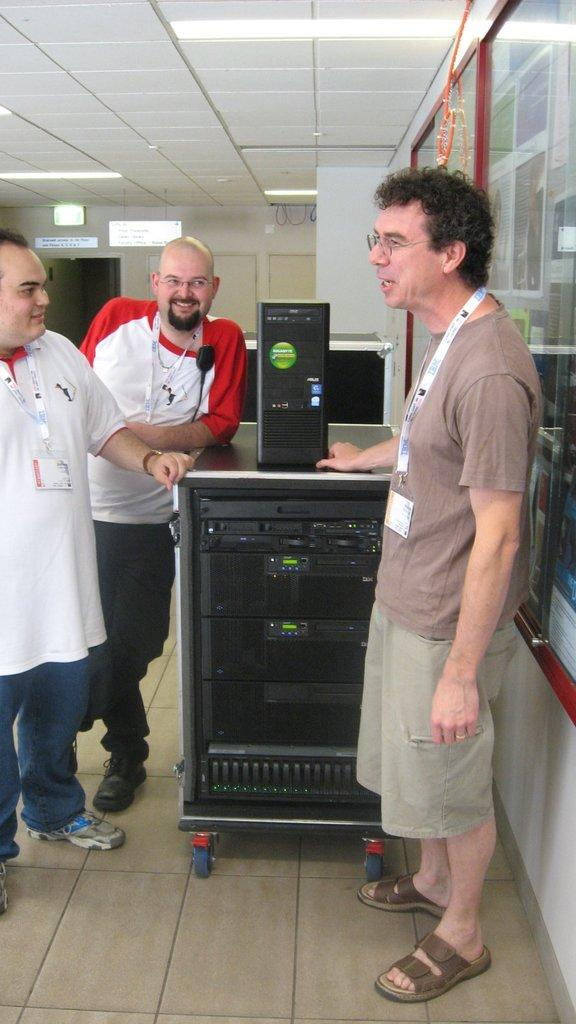How many people are in the image? There are three people in the image. What are the people doing in the image? The people are smiling in the image. Where are the people standing in the image? The people are standing on the floor in the image. What else can be seen in the image besides the people? There are electronic devices and light arrangements on the roof in the image. How many robins are perched on the electronic devices in the image? There are no robins present in the image. 